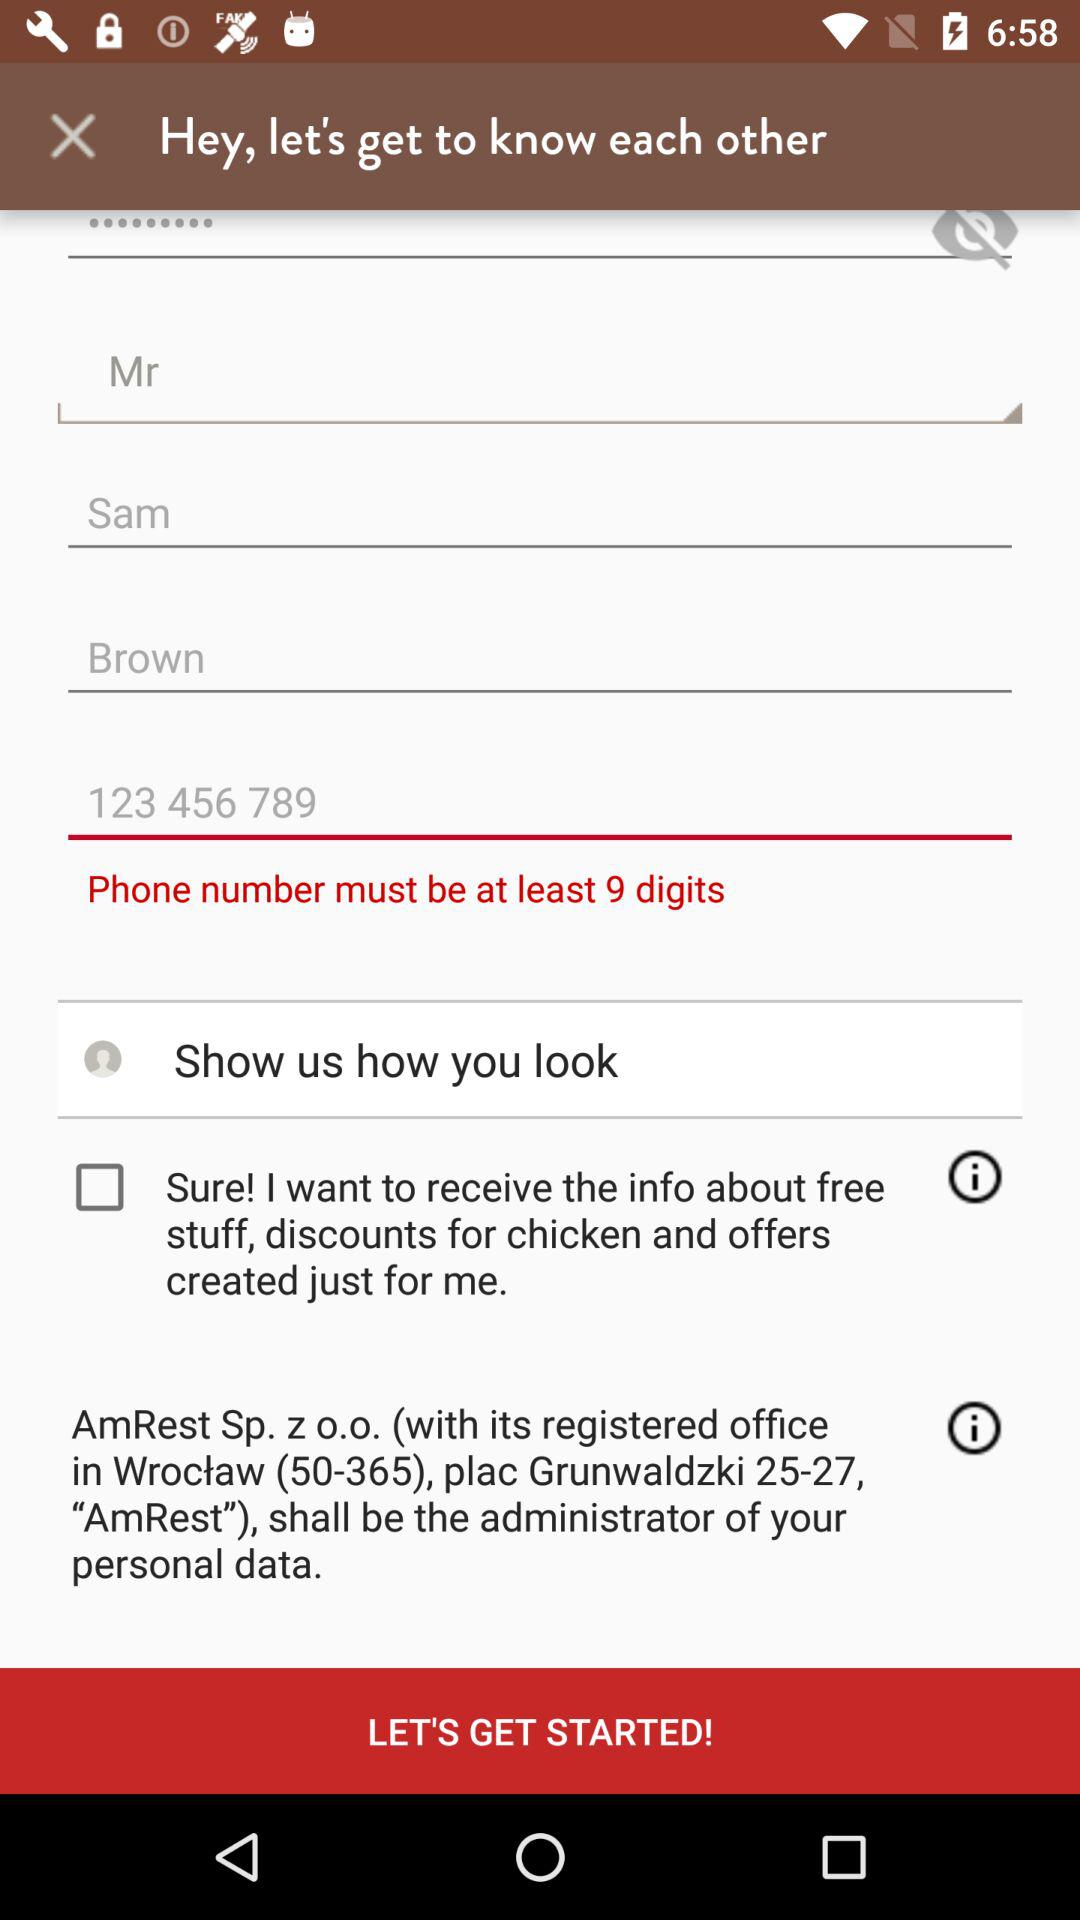What is the address of the registered office? The address of the registered office is Wrocław (50-365), plac Grunwaldzki 25-27, "AmRest". 